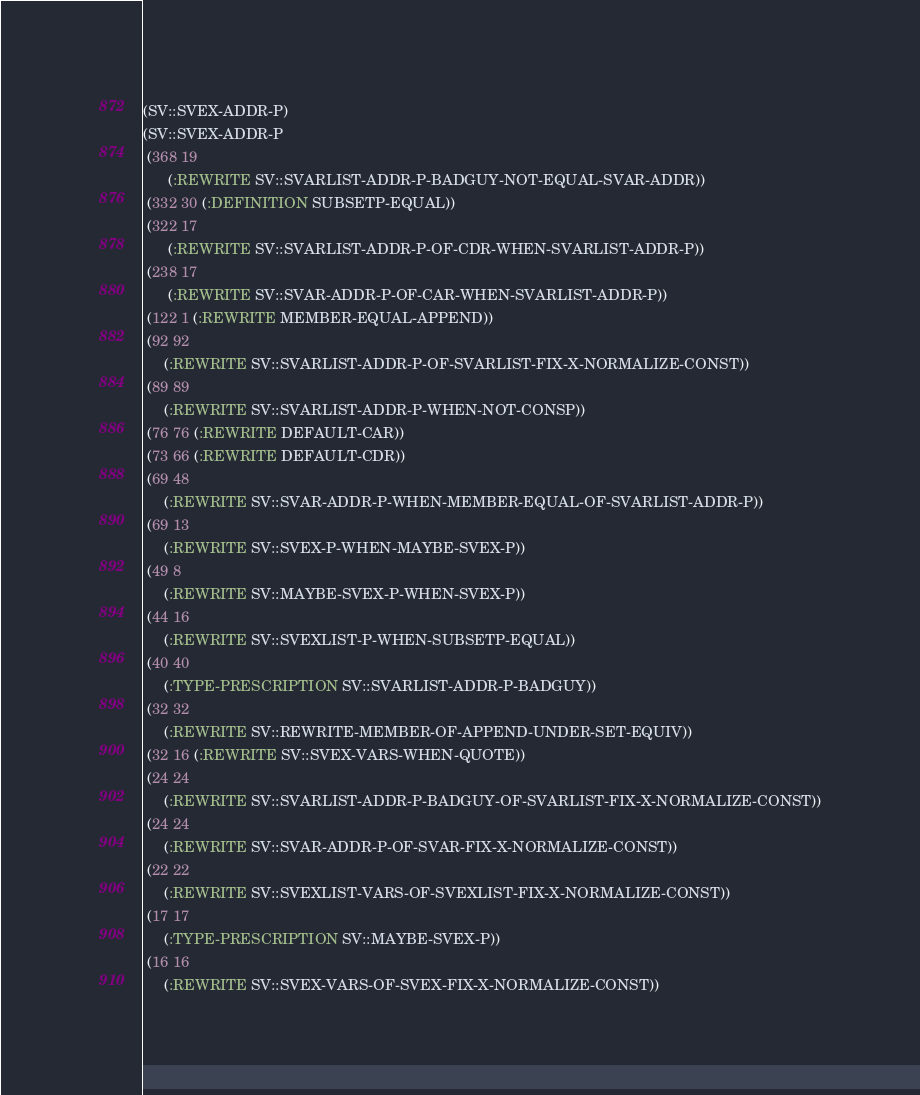<code> <loc_0><loc_0><loc_500><loc_500><_Lisp_>(SV::SVEX-ADDR-P)
(SV::SVEX-ADDR-P
 (368 19
      (:REWRITE SV::SVARLIST-ADDR-P-BADGUY-NOT-EQUAL-SVAR-ADDR))
 (332 30 (:DEFINITION SUBSETP-EQUAL))
 (322 17
      (:REWRITE SV::SVARLIST-ADDR-P-OF-CDR-WHEN-SVARLIST-ADDR-P))
 (238 17
      (:REWRITE SV::SVAR-ADDR-P-OF-CAR-WHEN-SVARLIST-ADDR-P))
 (122 1 (:REWRITE MEMBER-EQUAL-APPEND))
 (92 92
     (:REWRITE SV::SVARLIST-ADDR-P-OF-SVARLIST-FIX-X-NORMALIZE-CONST))
 (89 89
     (:REWRITE SV::SVARLIST-ADDR-P-WHEN-NOT-CONSP))
 (76 76 (:REWRITE DEFAULT-CAR))
 (73 66 (:REWRITE DEFAULT-CDR))
 (69 48
     (:REWRITE SV::SVAR-ADDR-P-WHEN-MEMBER-EQUAL-OF-SVARLIST-ADDR-P))
 (69 13
     (:REWRITE SV::SVEX-P-WHEN-MAYBE-SVEX-P))
 (49 8
     (:REWRITE SV::MAYBE-SVEX-P-WHEN-SVEX-P))
 (44 16
     (:REWRITE SV::SVEXLIST-P-WHEN-SUBSETP-EQUAL))
 (40 40
     (:TYPE-PRESCRIPTION SV::SVARLIST-ADDR-P-BADGUY))
 (32 32
     (:REWRITE SV::REWRITE-MEMBER-OF-APPEND-UNDER-SET-EQUIV))
 (32 16 (:REWRITE SV::SVEX-VARS-WHEN-QUOTE))
 (24 24
     (:REWRITE SV::SVARLIST-ADDR-P-BADGUY-OF-SVARLIST-FIX-X-NORMALIZE-CONST))
 (24 24
     (:REWRITE SV::SVAR-ADDR-P-OF-SVAR-FIX-X-NORMALIZE-CONST))
 (22 22
     (:REWRITE SV::SVEXLIST-VARS-OF-SVEXLIST-FIX-X-NORMALIZE-CONST))
 (17 17
     (:TYPE-PRESCRIPTION SV::MAYBE-SVEX-P))
 (16 16
     (:REWRITE SV::SVEX-VARS-OF-SVEX-FIX-X-NORMALIZE-CONST))</code> 